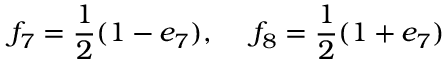<formula> <loc_0><loc_0><loc_500><loc_500>f _ { 7 } = \frac { 1 } { 2 } ( 1 - e _ { 7 } ) , f _ { 8 } = \frac { 1 } { 2 } ( 1 + e _ { 7 } )</formula> 